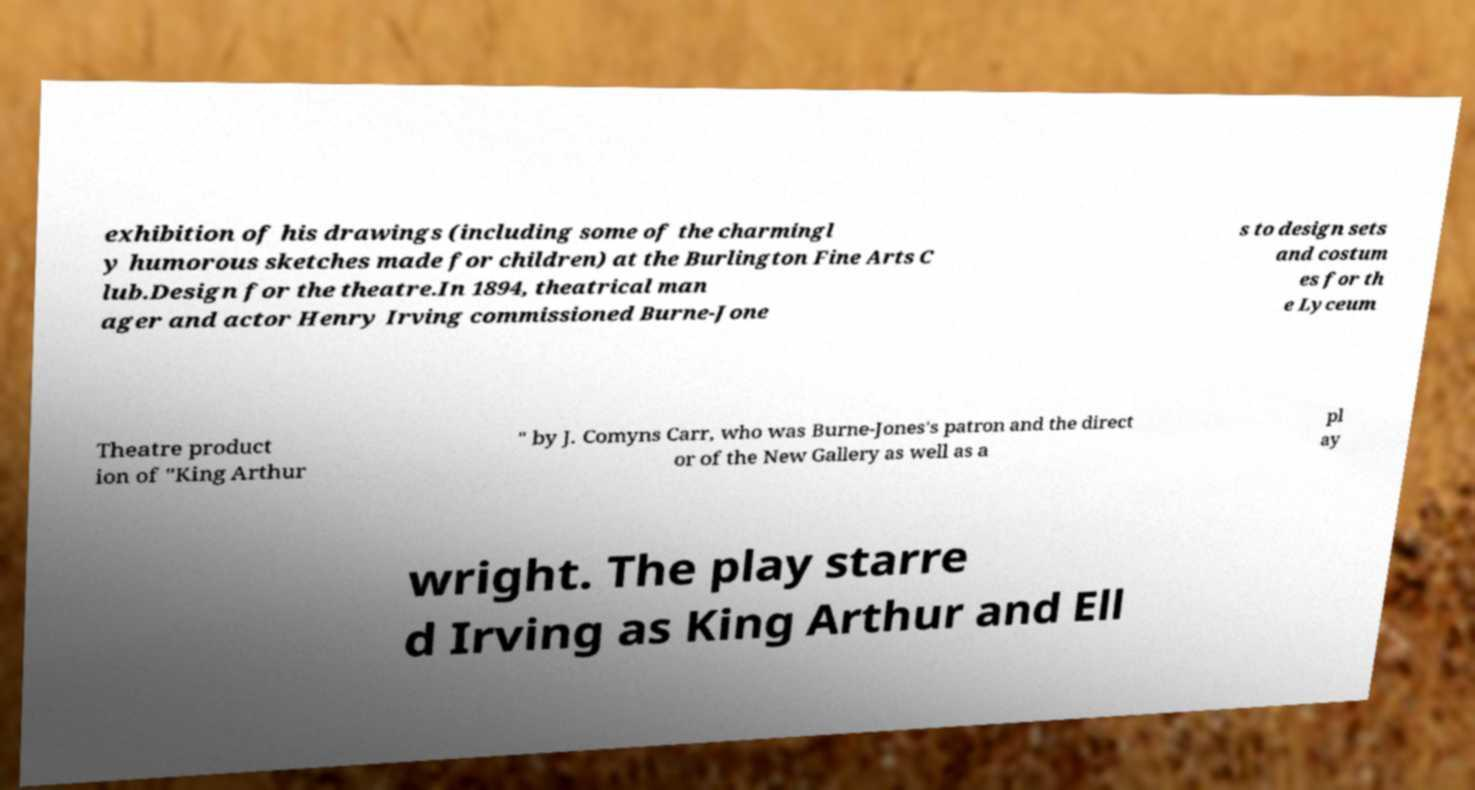Can you accurately transcribe the text from the provided image for me? exhibition of his drawings (including some of the charmingl y humorous sketches made for children) at the Burlington Fine Arts C lub.Design for the theatre.In 1894, theatrical man ager and actor Henry Irving commissioned Burne-Jone s to design sets and costum es for th e Lyceum Theatre product ion of "King Arthur " by J. Comyns Carr, who was Burne-Jones's patron and the direct or of the New Gallery as well as a pl ay wright. The play starre d Irving as King Arthur and Ell 